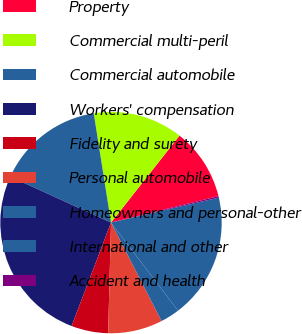Convert chart. <chart><loc_0><loc_0><loc_500><loc_500><pie_chart><fcel>Property<fcel>Commercial multi-peril<fcel>Commercial automobile<fcel>Workers' compensation<fcel>Fidelity and surety<fcel>Personal automobile<fcel>Homeowners and personal-other<fcel>International and other<fcel>Accident and health<nl><fcel>10.54%<fcel>13.12%<fcel>15.7%<fcel>26.02%<fcel>5.38%<fcel>7.96%<fcel>2.8%<fcel>18.28%<fcel>0.22%<nl></chart> 